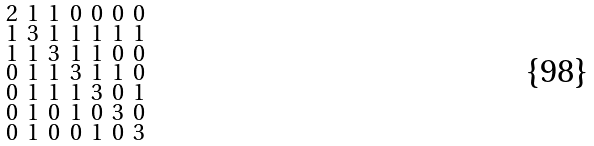<formula> <loc_0><loc_0><loc_500><loc_500>\begin{smallmatrix} 2 & 1 & 1 & 0 & 0 & 0 & 0 \\ 1 & 3 & 1 & 1 & 1 & 1 & 1 \\ 1 & 1 & 3 & 1 & 1 & 0 & 0 \\ 0 & 1 & 1 & 3 & 1 & 1 & 0 \\ 0 & 1 & 1 & 1 & 3 & 0 & 1 \\ 0 & 1 & 0 & 1 & 0 & 3 & 0 \\ 0 & 1 & 0 & 0 & 1 & 0 & 3 \end{smallmatrix}</formula> 